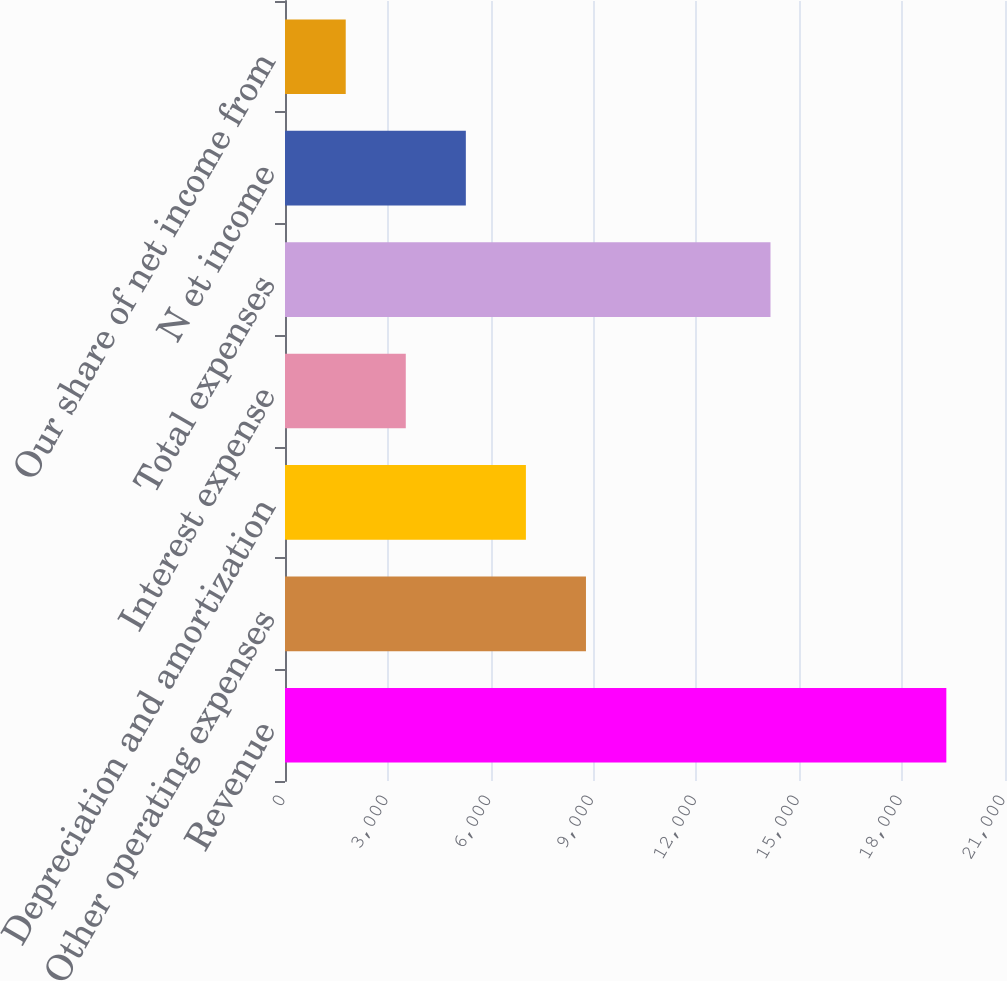<chart> <loc_0><loc_0><loc_500><loc_500><bar_chart><fcel>Revenue<fcel>Other operating expenses<fcel>Depreciation and amortization<fcel>Interest expense<fcel>Total expenses<fcel>N et income<fcel>Our share of net income from<nl><fcel>19289<fcel>8778.2<fcel>7026.4<fcel>3522.8<fcel>14160<fcel>5274.6<fcel>1771<nl></chart> 